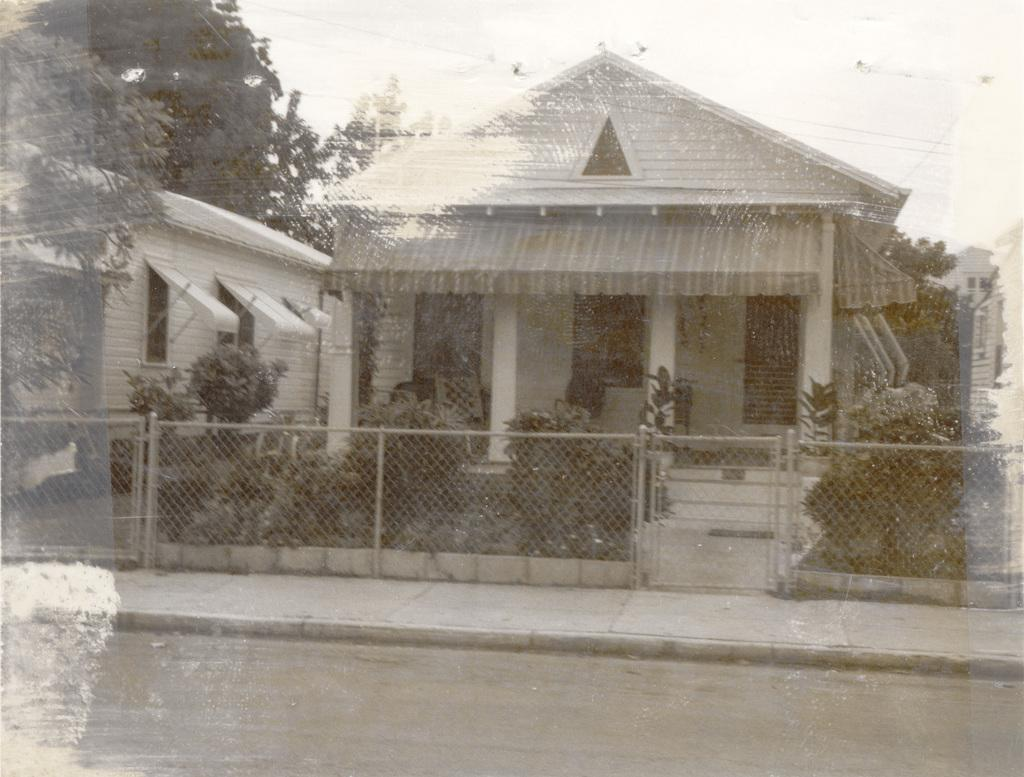What type of structures can be seen in the image? There are houses in the image. What other natural elements are present in the image? There are plants, trees, and the sky visible in the image. Are there any architectural features in the image? Yes, there are stairs and a fence in the image. What is at the bottom of the image? There is a path and a road at the bottom of the image. What type of hammer can be seen hanging on the fence in the image? There is no hammer present in the image; it only features houses, plants, stairs, trees, a fence, the sky, a path, and a road. What kind of pot is placed on the roof of the house in the image? There is no pot visible on any of the houses in the image. 